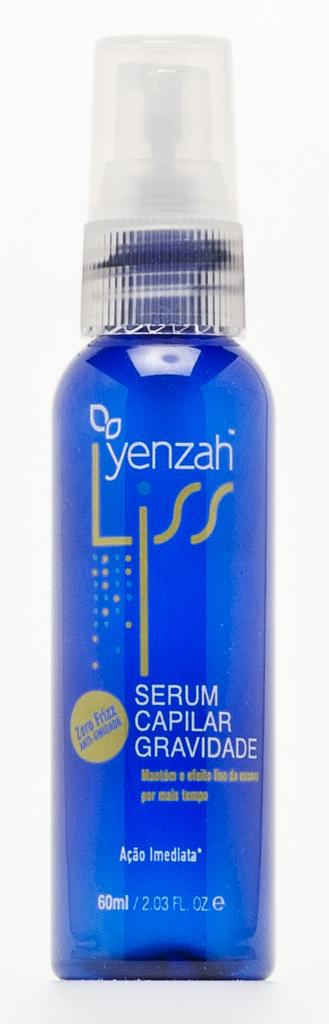<image>
Create a compact narrative representing the image presented. A blue bottle with Yenzah Liss written on the side of it. 